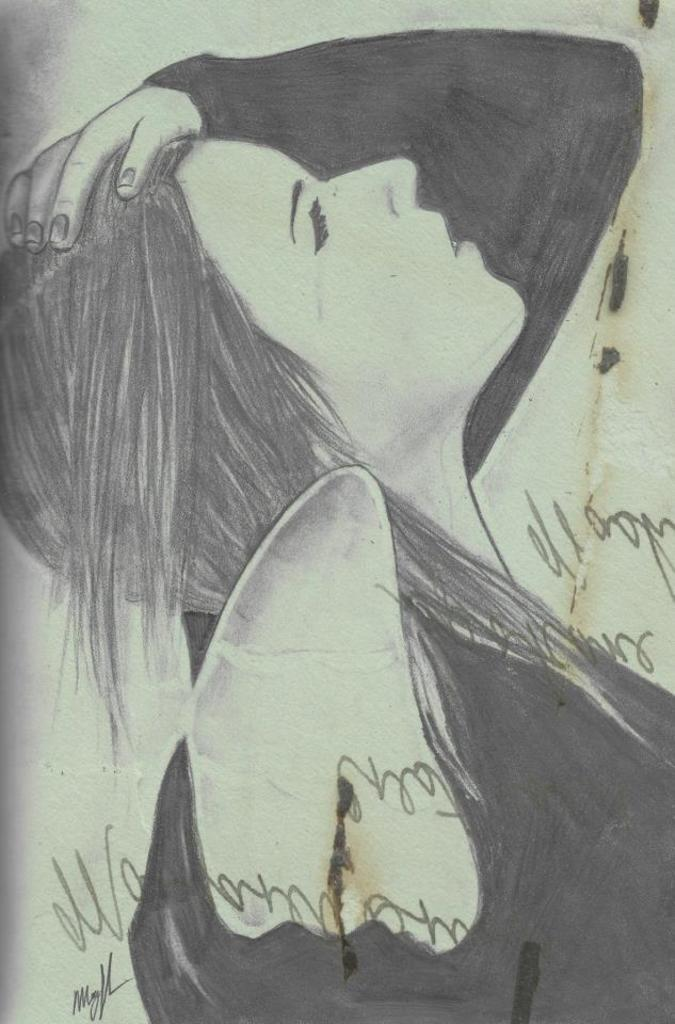What is the main subject of the image? The main subject of the image is a pencil sketch of a lady. What can be seen in addition to the pencil sketch? There is text on the image. What type of plastic material is used to create the man in the image? There is no man present in the image, and no plastic material is mentioned in the facts provided. 